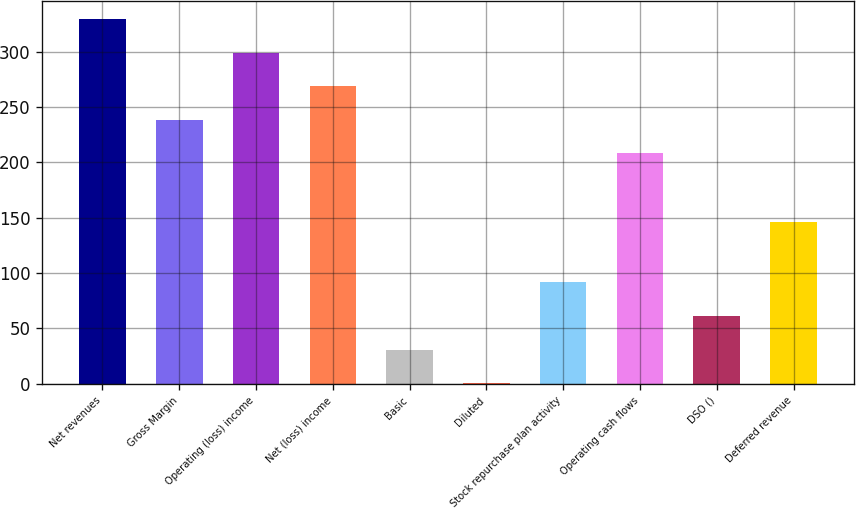Convert chart to OTSL. <chart><loc_0><loc_0><loc_500><loc_500><bar_chart><fcel>Net revenues<fcel>Gross Margin<fcel>Operating (loss) income<fcel>Net (loss) income<fcel>Basic<fcel>Diluted<fcel>Stock repurchase plan activity<fcel>Operating cash flows<fcel>DSO ()<fcel>Deferred revenue<nl><fcel>329.48<fcel>238.52<fcel>299.16<fcel>268.84<fcel>30.83<fcel>0.51<fcel>91.47<fcel>208.2<fcel>61.15<fcel>145.9<nl></chart> 